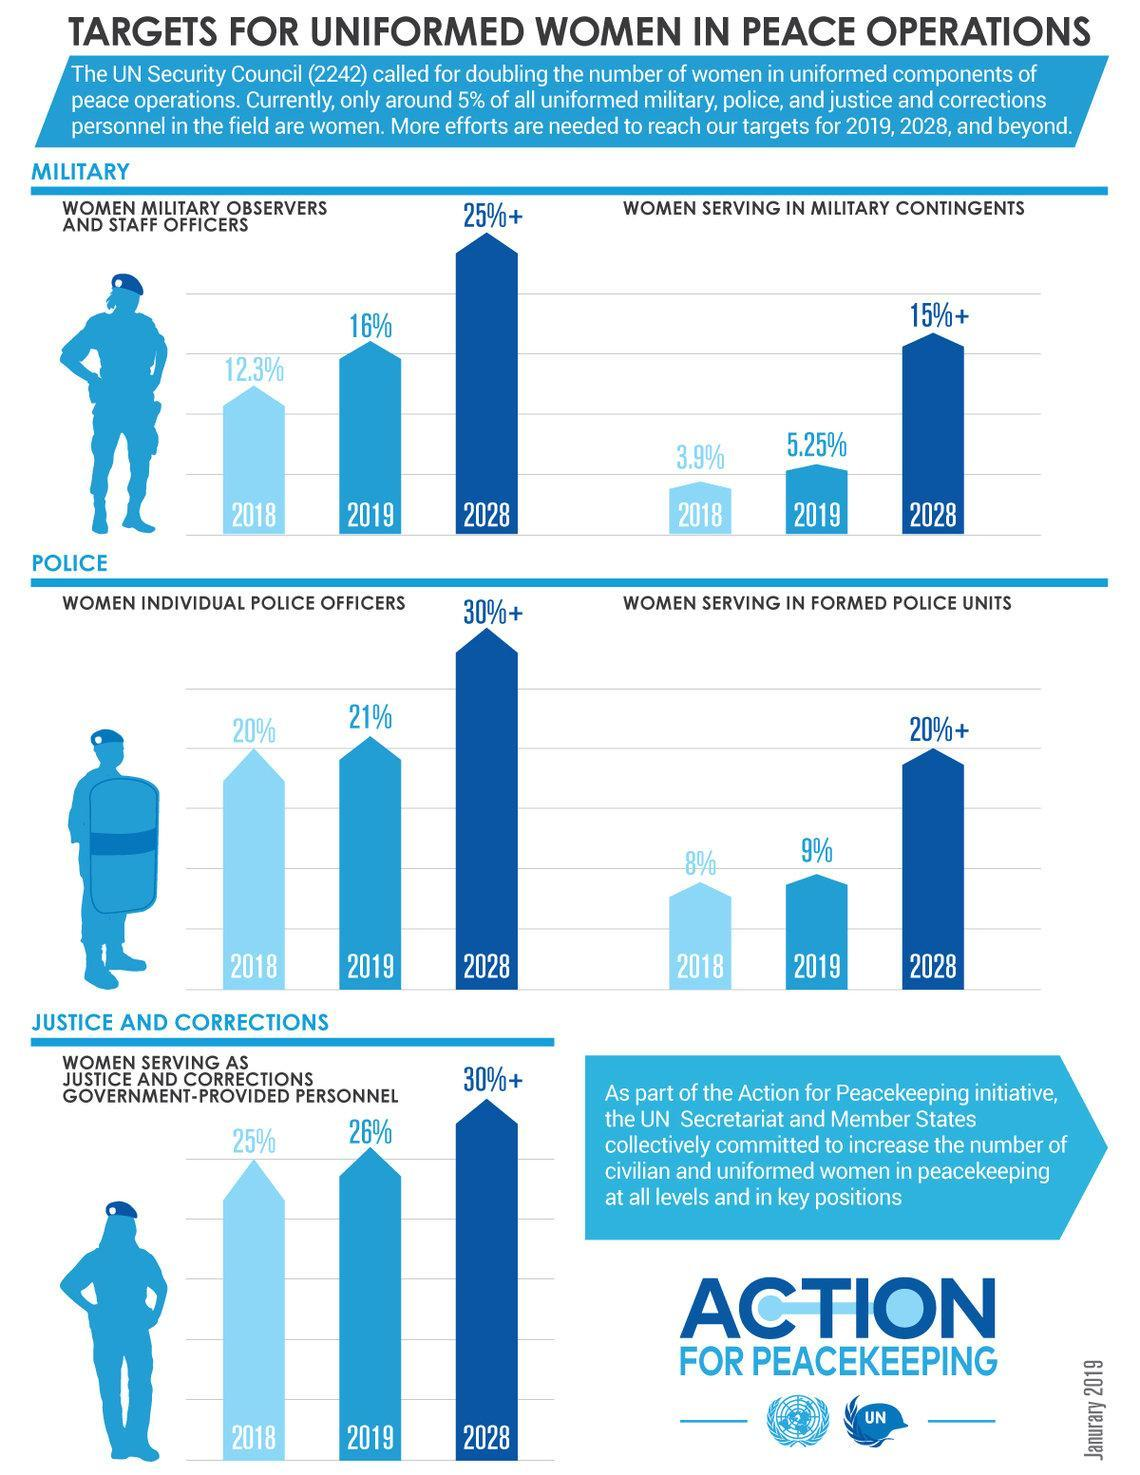What is the increase in percentage in women serving as justice and corrections government-provided personnel from 2018 to 2019?
Answer the question with a short phrase. 1% What is the increase in percentage in women serving in military contingents from 2018 to 2019? 1.35% What is the target year to see the increase in number of civilian and uniformed women in peacekeeping and at all levels and in key positions? 2028 What is the increase in percentage in women military observers and staff officers from 2018 to 2019? 3.7% What is the increase in percentage in women serving in formed police units from 2018 to 2019? 1% What is the increase in percentage in women individual police officers from 2018 to 2019? 1% 